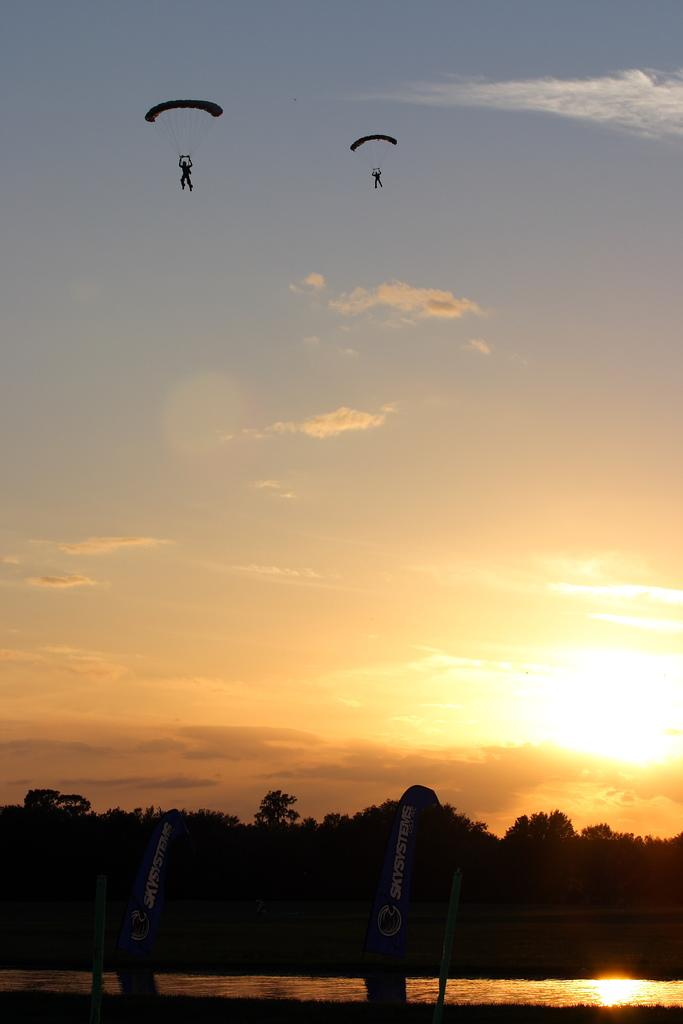How many people are in the image? There are two people in the image. What are the people doing in the image? The people are flying and holding parachutes. What type of vegetation can be seen in the image? There are trees visible in the image. What natural element can be seen in the image? There is water visible in the image. What objects are present in the image? There are boards in the image. How is the sky depicted in the image? The sky is in white, blue, and yellow colors, and the sun is observable in the sky. What type of protest is happening in the image? There is no protest mentioned or depicted in the image. How many boys are present in the image? The facts provided do not mention the gender of the people in the image, so we cannot determine if they are boys or not. 